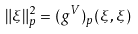Convert formula to latex. <formula><loc_0><loc_0><loc_500><loc_500>\| \xi \| _ { p } ^ { 2 } = ( g ^ { V } ) _ { p } ( \xi , \xi )</formula> 